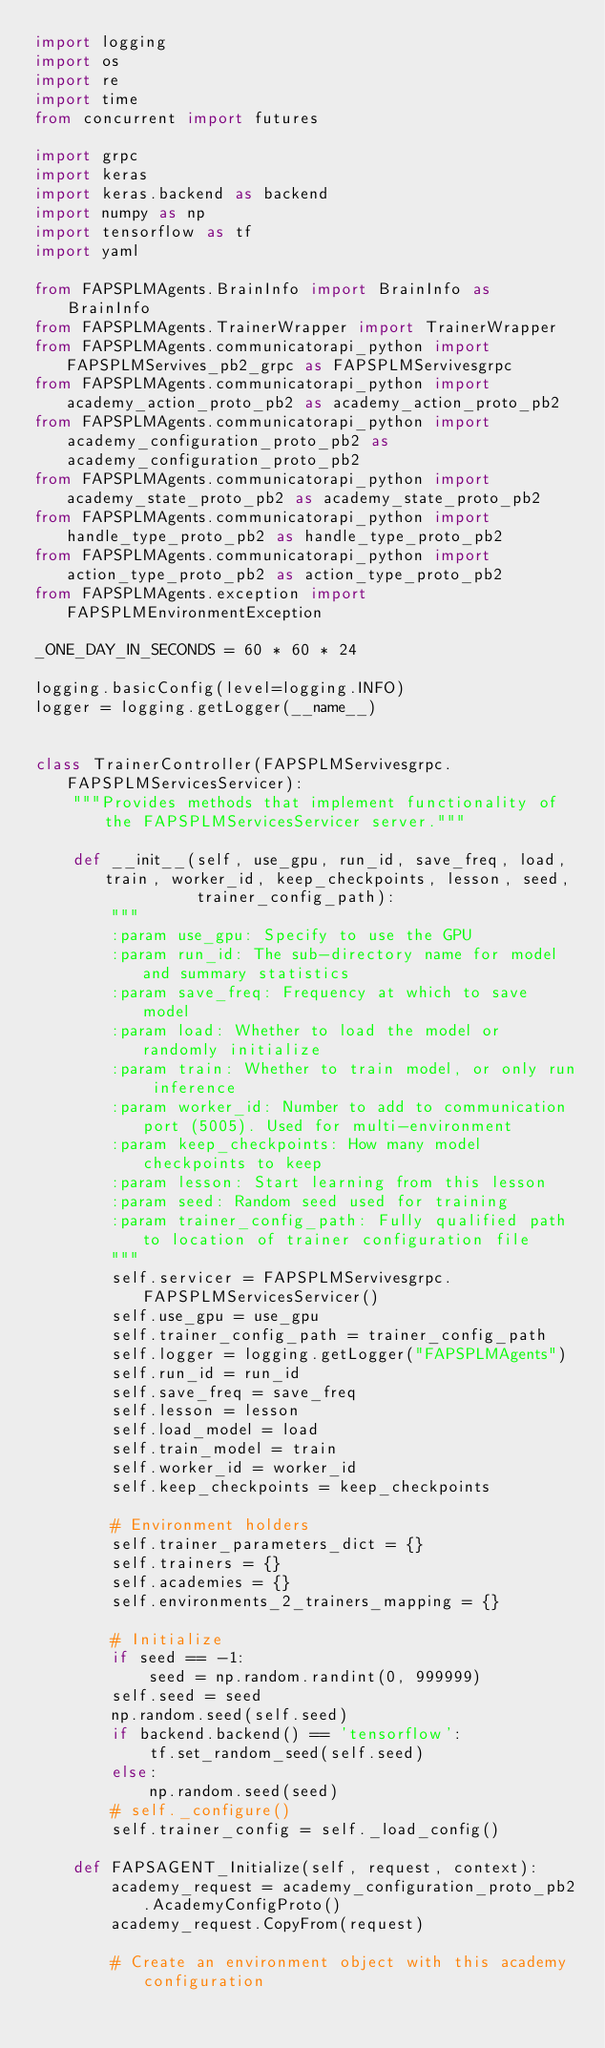<code> <loc_0><loc_0><loc_500><loc_500><_Python_>import logging
import os
import re
import time
from concurrent import futures

import grpc
import keras
import keras.backend as backend
import numpy as np
import tensorflow as tf
import yaml

from FAPSPLMAgents.BrainInfo import BrainInfo as BrainInfo
from FAPSPLMAgents.TrainerWrapper import TrainerWrapper
from FAPSPLMAgents.communicatorapi_python import FAPSPLMServives_pb2_grpc as FAPSPLMServivesgrpc
from FAPSPLMAgents.communicatorapi_python import academy_action_proto_pb2 as academy_action_proto_pb2
from FAPSPLMAgents.communicatorapi_python import academy_configuration_proto_pb2 as academy_configuration_proto_pb2
from FAPSPLMAgents.communicatorapi_python import academy_state_proto_pb2 as academy_state_proto_pb2
from FAPSPLMAgents.communicatorapi_python import handle_type_proto_pb2 as handle_type_proto_pb2
from FAPSPLMAgents.communicatorapi_python import action_type_proto_pb2 as action_type_proto_pb2
from FAPSPLMAgents.exception import FAPSPLMEnvironmentException

_ONE_DAY_IN_SECONDS = 60 * 60 * 24

logging.basicConfig(level=logging.INFO)
logger = logging.getLogger(__name__)


class TrainerController(FAPSPLMServivesgrpc.FAPSPLMServicesServicer):
    """Provides methods that implement functionality of the FAPSPLMServicesServicer server."""

    def __init__(self, use_gpu, run_id, save_freq, load, train, worker_id, keep_checkpoints, lesson, seed,
                 trainer_config_path):
        """
        :param use_gpu: Specify to use the GPU
        :param run_id: The sub-directory name for model and summary statistics
        :param save_freq: Frequency at which to save model
        :param load: Whether to load the model or randomly initialize
        :param train: Whether to train model, or only run inference
        :param worker_id: Number to add to communication port (5005). Used for multi-environment
        :param keep_checkpoints: How many model checkpoints to keep
        :param lesson: Start learning from this lesson
        :param seed: Random seed used for training
        :param trainer_config_path: Fully qualified path to location of trainer configuration file
        """
        self.servicer = FAPSPLMServivesgrpc.FAPSPLMServicesServicer()
        self.use_gpu = use_gpu
        self.trainer_config_path = trainer_config_path
        self.logger = logging.getLogger("FAPSPLMAgents")
        self.run_id = run_id
        self.save_freq = save_freq
        self.lesson = lesson
        self.load_model = load
        self.train_model = train
        self.worker_id = worker_id
        self.keep_checkpoints = keep_checkpoints

        # Environment holders
        self.trainer_parameters_dict = {}
        self.trainers = {}
        self.academies = {}
        self.environments_2_trainers_mapping = {}

        # Initialize
        if seed == -1:
            seed = np.random.randint(0, 999999)
        self.seed = seed
        np.random.seed(self.seed)
        if backend.backend() == 'tensorflow':
            tf.set_random_seed(self.seed)
        else:
            np.random.seed(seed)
        # self._configure()
        self.trainer_config = self._load_config()

    def FAPSAGENT_Initialize(self, request, context):
        academy_request = academy_configuration_proto_pb2.AcademyConfigProto()
        academy_request.CopyFrom(request)

        # Create an environment object with this academy configuration</code> 